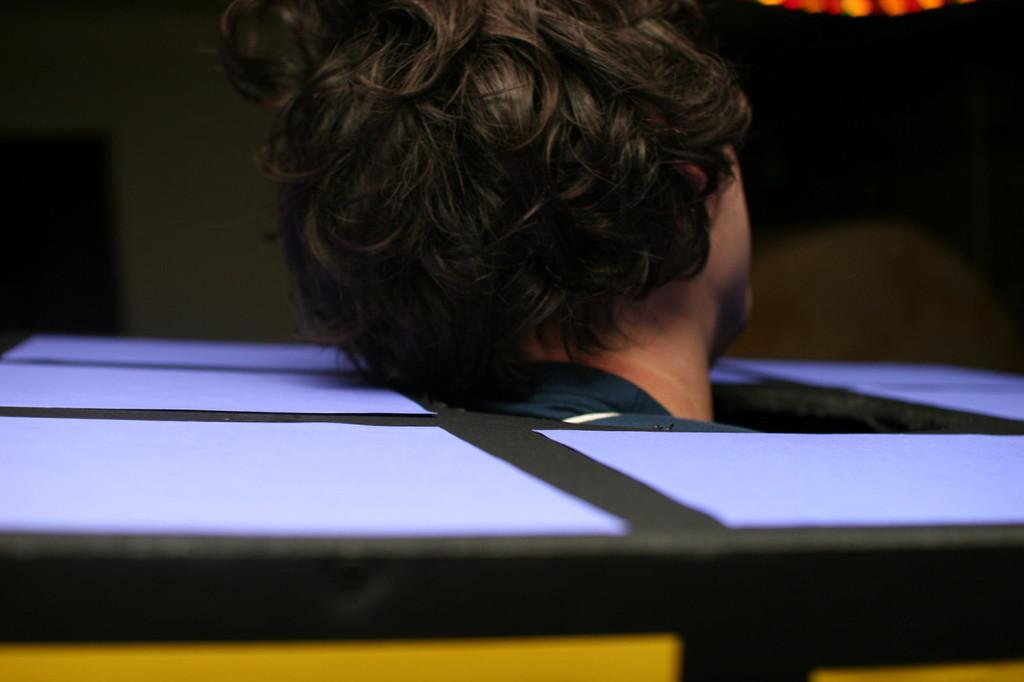Who or what is present in the image? There is a person in the image. What is the person's location or situation in the image? The person is inside a box. What can be observed about the overall appearance of the image? The background of the image is dark. What type of plant can be seen growing in the market in the image? There is no market or plant present in the image; it features a person inside a box with a dark background. 